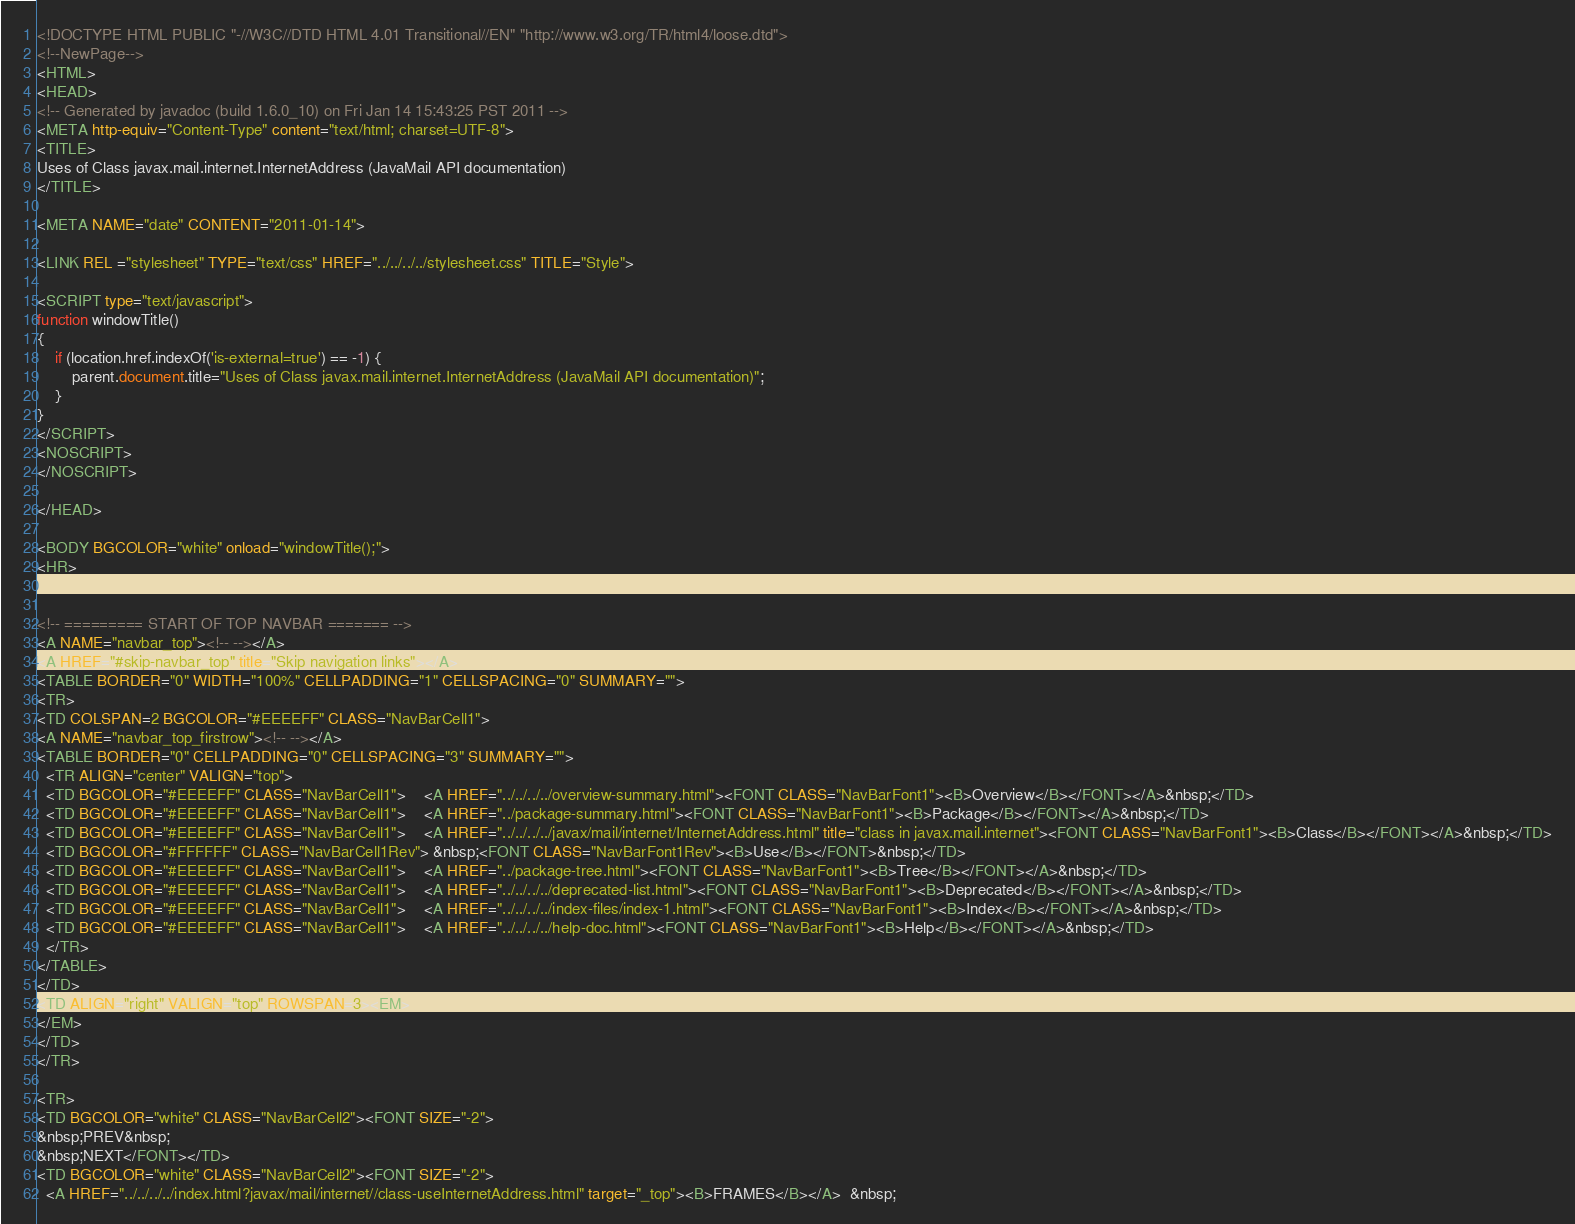<code> <loc_0><loc_0><loc_500><loc_500><_HTML_><!DOCTYPE HTML PUBLIC "-//W3C//DTD HTML 4.01 Transitional//EN" "http://www.w3.org/TR/html4/loose.dtd">
<!--NewPage-->
<HTML>
<HEAD>
<!-- Generated by javadoc (build 1.6.0_10) on Fri Jan 14 15:43:25 PST 2011 -->
<META http-equiv="Content-Type" content="text/html; charset=UTF-8">
<TITLE>
Uses of Class javax.mail.internet.InternetAddress (JavaMail API documentation)
</TITLE>

<META NAME="date" CONTENT="2011-01-14">

<LINK REL ="stylesheet" TYPE="text/css" HREF="../../../../stylesheet.css" TITLE="Style">

<SCRIPT type="text/javascript">
function windowTitle()
{
    if (location.href.indexOf('is-external=true') == -1) {
        parent.document.title="Uses of Class javax.mail.internet.InternetAddress (JavaMail API documentation)";
    }
}
</SCRIPT>
<NOSCRIPT>
</NOSCRIPT>

</HEAD>

<BODY BGCOLOR="white" onload="windowTitle();">
<HR>


<!-- ========= START OF TOP NAVBAR ======= -->
<A NAME="navbar_top"><!-- --></A>
<A HREF="#skip-navbar_top" title="Skip navigation links"></A>
<TABLE BORDER="0" WIDTH="100%" CELLPADDING="1" CELLSPACING="0" SUMMARY="">
<TR>
<TD COLSPAN=2 BGCOLOR="#EEEEFF" CLASS="NavBarCell1">
<A NAME="navbar_top_firstrow"><!-- --></A>
<TABLE BORDER="0" CELLPADDING="0" CELLSPACING="3" SUMMARY="">
  <TR ALIGN="center" VALIGN="top">
  <TD BGCOLOR="#EEEEFF" CLASS="NavBarCell1">    <A HREF="../../../../overview-summary.html"><FONT CLASS="NavBarFont1"><B>Overview</B></FONT></A>&nbsp;</TD>
  <TD BGCOLOR="#EEEEFF" CLASS="NavBarCell1">    <A HREF="../package-summary.html"><FONT CLASS="NavBarFont1"><B>Package</B></FONT></A>&nbsp;</TD>
  <TD BGCOLOR="#EEEEFF" CLASS="NavBarCell1">    <A HREF="../../../../javax/mail/internet/InternetAddress.html" title="class in javax.mail.internet"><FONT CLASS="NavBarFont1"><B>Class</B></FONT></A>&nbsp;</TD>
  <TD BGCOLOR="#FFFFFF" CLASS="NavBarCell1Rev"> &nbsp;<FONT CLASS="NavBarFont1Rev"><B>Use</B></FONT>&nbsp;</TD>
  <TD BGCOLOR="#EEEEFF" CLASS="NavBarCell1">    <A HREF="../package-tree.html"><FONT CLASS="NavBarFont1"><B>Tree</B></FONT></A>&nbsp;</TD>
  <TD BGCOLOR="#EEEEFF" CLASS="NavBarCell1">    <A HREF="../../../../deprecated-list.html"><FONT CLASS="NavBarFont1"><B>Deprecated</B></FONT></A>&nbsp;</TD>
  <TD BGCOLOR="#EEEEFF" CLASS="NavBarCell1">    <A HREF="../../../../index-files/index-1.html"><FONT CLASS="NavBarFont1"><B>Index</B></FONT></A>&nbsp;</TD>
  <TD BGCOLOR="#EEEEFF" CLASS="NavBarCell1">    <A HREF="../../../../help-doc.html"><FONT CLASS="NavBarFont1"><B>Help</B></FONT></A>&nbsp;</TD>
  </TR>
</TABLE>
</TD>
<TD ALIGN="right" VALIGN="top" ROWSPAN=3><EM>
</EM>
</TD>
</TR>

<TR>
<TD BGCOLOR="white" CLASS="NavBarCell2"><FONT SIZE="-2">
&nbsp;PREV&nbsp;
&nbsp;NEXT</FONT></TD>
<TD BGCOLOR="white" CLASS="NavBarCell2"><FONT SIZE="-2">
  <A HREF="../../../../index.html?javax/mail/internet//class-useInternetAddress.html" target="_top"><B>FRAMES</B></A>  &nbsp;</code> 